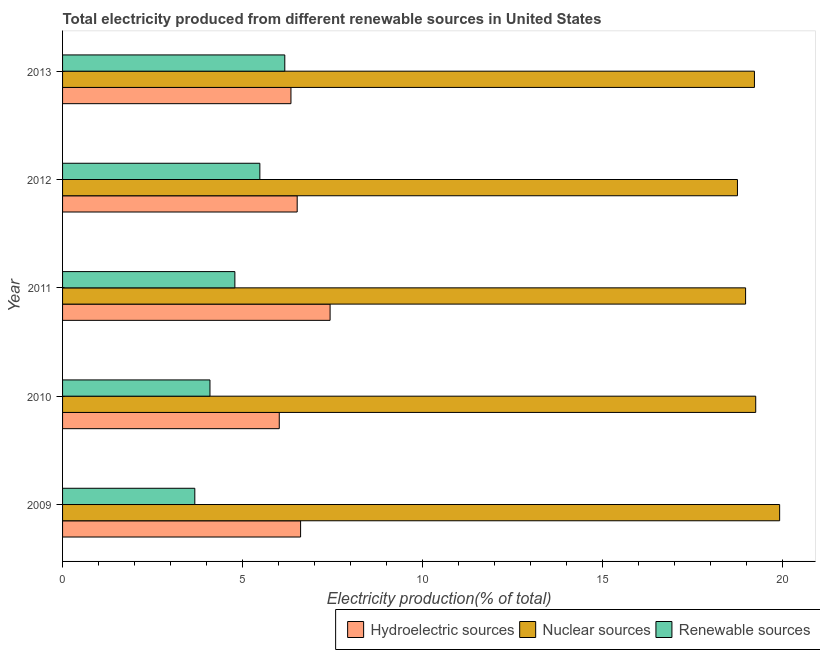How many different coloured bars are there?
Your answer should be compact. 3. Are the number of bars on each tick of the Y-axis equal?
Your response must be concise. Yes. How many bars are there on the 4th tick from the top?
Keep it short and to the point. 3. How many bars are there on the 2nd tick from the bottom?
Provide a short and direct response. 3. What is the label of the 1st group of bars from the top?
Provide a short and direct response. 2013. What is the percentage of electricity produced by renewable sources in 2011?
Ensure brevity in your answer.  4.79. Across all years, what is the maximum percentage of electricity produced by hydroelectric sources?
Your answer should be compact. 7.44. Across all years, what is the minimum percentage of electricity produced by renewable sources?
Make the answer very short. 3.68. In which year was the percentage of electricity produced by hydroelectric sources maximum?
Offer a very short reply. 2011. What is the total percentage of electricity produced by renewable sources in the graph?
Provide a succinct answer. 24.22. What is the difference between the percentage of electricity produced by renewable sources in 2009 and that in 2010?
Ensure brevity in your answer.  -0.42. What is the difference between the percentage of electricity produced by nuclear sources in 2009 and the percentage of electricity produced by hydroelectric sources in 2013?
Your response must be concise. 13.58. What is the average percentage of electricity produced by hydroelectric sources per year?
Make the answer very short. 6.59. In the year 2011, what is the difference between the percentage of electricity produced by nuclear sources and percentage of electricity produced by hydroelectric sources?
Make the answer very short. 11.55. In how many years, is the percentage of electricity produced by renewable sources greater than 7 %?
Give a very brief answer. 0. What is the ratio of the percentage of electricity produced by nuclear sources in 2009 to that in 2013?
Offer a terse response. 1.04. Is the percentage of electricity produced by hydroelectric sources in 2009 less than that in 2010?
Offer a very short reply. No. Is the difference between the percentage of electricity produced by hydroelectric sources in 2011 and 2012 greater than the difference between the percentage of electricity produced by nuclear sources in 2011 and 2012?
Offer a very short reply. Yes. What is the difference between the highest and the second highest percentage of electricity produced by hydroelectric sources?
Your answer should be very brief. 0.82. What is the difference between the highest and the lowest percentage of electricity produced by renewable sources?
Ensure brevity in your answer.  2.5. What does the 2nd bar from the top in 2013 represents?
Your response must be concise. Nuclear sources. What does the 1st bar from the bottom in 2009 represents?
Offer a very short reply. Hydroelectric sources. Is it the case that in every year, the sum of the percentage of electricity produced by hydroelectric sources and percentage of electricity produced by nuclear sources is greater than the percentage of electricity produced by renewable sources?
Ensure brevity in your answer.  Yes. How many years are there in the graph?
Your answer should be very brief. 5. What is the difference between two consecutive major ticks on the X-axis?
Your answer should be very brief. 5. Are the values on the major ticks of X-axis written in scientific E-notation?
Offer a very short reply. No. How are the legend labels stacked?
Provide a short and direct response. Horizontal. What is the title of the graph?
Offer a very short reply. Total electricity produced from different renewable sources in United States. What is the label or title of the X-axis?
Make the answer very short. Electricity production(% of total). What is the label or title of the Y-axis?
Give a very brief answer. Year. What is the Electricity production(% of total) of Hydroelectric sources in 2009?
Provide a succinct answer. 6.62. What is the Electricity production(% of total) in Nuclear sources in 2009?
Offer a very short reply. 19.93. What is the Electricity production(% of total) of Renewable sources in 2009?
Give a very brief answer. 3.68. What is the Electricity production(% of total) of Hydroelectric sources in 2010?
Keep it short and to the point. 6.02. What is the Electricity production(% of total) of Nuclear sources in 2010?
Provide a succinct answer. 19.27. What is the Electricity production(% of total) of Renewable sources in 2010?
Your answer should be very brief. 4.1. What is the Electricity production(% of total) of Hydroelectric sources in 2011?
Make the answer very short. 7.44. What is the Electricity production(% of total) in Nuclear sources in 2011?
Give a very brief answer. 18.98. What is the Electricity production(% of total) in Renewable sources in 2011?
Give a very brief answer. 4.79. What is the Electricity production(% of total) of Hydroelectric sources in 2012?
Provide a succinct answer. 6.52. What is the Electricity production(% of total) in Nuclear sources in 2012?
Your answer should be compact. 18.76. What is the Electricity production(% of total) of Renewable sources in 2012?
Offer a very short reply. 5.48. What is the Electricity production(% of total) of Hydroelectric sources in 2013?
Make the answer very short. 6.35. What is the Electricity production(% of total) in Nuclear sources in 2013?
Keep it short and to the point. 19.23. What is the Electricity production(% of total) in Renewable sources in 2013?
Make the answer very short. 6.18. Across all years, what is the maximum Electricity production(% of total) of Hydroelectric sources?
Ensure brevity in your answer.  7.44. Across all years, what is the maximum Electricity production(% of total) of Nuclear sources?
Provide a succinct answer. 19.93. Across all years, what is the maximum Electricity production(% of total) of Renewable sources?
Provide a succinct answer. 6.18. Across all years, what is the minimum Electricity production(% of total) in Hydroelectric sources?
Offer a very short reply. 6.02. Across all years, what is the minimum Electricity production(% of total) in Nuclear sources?
Keep it short and to the point. 18.76. Across all years, what is the minimum Electricity production(% of total) in Renewable sources?
Your response must be concise. 3.68. What is the total Electricity production(% of total) in Hydroelectric sources in the graph?
Offer a very short reply. 32.94. What is the total Electricity production(% of total) in Nuclear sources in the graph?
Give a very brief answer. 96.17. What is the total Electricity production(% of total) of Renewable sources in the graph?
Offer a terse response. 24.22. What is the difference between the Electricity production(% of total) in Hydroelectric sources in 2009 and that in 2010?
Keep it short and to the point. 0.59. What is the difference between the Electricity production(% of total) in Nuclear sources in 2009 and that in 2010?
Offer a very short reply. 0.66. What is the difference between the Electricity production(% of total) of Renewable sources in 2009 and that in 2010?
Keep it short and to the point. -0.42. What is the difference between the Electricity production(% of total) of Hydroelectric sources in 2009 and that in 2011?
Provide a succinct answer. -0.82. What is the difference between the Electricity production(% of total) in Nuclear sources in 2009 and that in 2011?
Ensure brevity in your answer.  0.95. What is the difference between the Electricity production(% of total) of Renewable sources in 2009 and that in 2011?
Your response must be concise. -1.11. What is the difference between the Electricity production(% of total) in Hydroelectric sources in 2009 and that in 2012?
Your response must be concise. 0.09. What is the difference between the Electricity production(% of total) in Nuclear sources in 2009 and that in 2012?
Your response must be concise. 1.17. What is the difference between the Electricity production(% of total) in Renewable sources in 2009 and that in 2012?
Your answer should be compact. -1.81. What is the difference between the Electricity production(% of total) of Hydroelectric sources in 2009 and that in 2013?
Your response must be concise. 0.27. What is the difference between the Electricity production(% of total) of Nuclear sources in 2009 and that in 2013?
Give a very brief answer. 0.7. What is the difference between the Electricity production(% of total) of Renewable sources in 2009 and that in 2013?
Offer a terse response. -2.5. What is the difference between the Electricity production(% of total) of Hydroelectric sources in 2010 and that in 2011?
Your answer should be compact. -1.41. What is the difference between the Electricity production(% of total) in Nuclear sources in 2010 and that in 2011?
Ensure brevity in your answer.  0.28. What is the difference between the Electricity production(% of total) of Renewable sources in 2010 and that in 2011?
Give a very brief answer. -0.69. What is the difference between the Electricity production(% of total) in Hydroelectric sources in 2010 and that in 2012?
Keep it short and to the point. -0.5. What is the difference between the Electricity production(% of total) of Nuclear sources in 2010 and that in 2012?
Give a very brief answer. 0.51. What is the difference between the Electricity production(% of total) of Renewable sources in 2010 and that in 2012?
Give a very brief answer. -1.39. What is the difference between the Electricity production(% of total) in Hydroelectric sources in 2010 and that in 2013?
Make the answer very short. -0.33. What is the difference between the Electricity production(% of total) of Nuclear sources in 2010 and that in 2013?
Ensure brevity in your answer.  0.04. What is the difference between the Electricity production(% of total) in Renewable sources in 2010 and that in 2013?
Provide a short and direct response. -2.08. What is the difference between the Electricity production(% of total) in Hydroelectric sources in 2011 and that in 2012?
Make the answer very short. 0.91. What is the difference between the Electricity production(% of total) of Nuclear sources in 2011 and that in 2012?
Offer a terse response. 0.23. What is the difference between the Electricity production(% of total) of Renewable sources in 2011 and that in 2012?
Give a very brief answer. -0.69. What is the difference between the Electricity production(% of total) of Hydroelectric sources in 2011 and that in 2013?
Your response must be concise. 1.09. What is the difference between the Electricity production(% of total) of Nuclear sources in 2011 and that in 2013?
Your answer should be very brief. -0.25. What is the difference between the Electricity production(% of total) in Renewable sources in 2011 and that in 2013?
Your answer should be compact. -1.39. What is the difference between the Electricity production(% of total) in Hydroelectric sources in 2012 and that in 2013?
Your answer should be very brief. 0.17. What is the difference between the Electricity production(% of total) in Nuclear sources in 2012 and that in 2013?
Ensure brevity in your answer.  -0.47. What is the difference between the Electricity production(% of total) of Renewable sources in 2012 and that in 2013?
Offer a very short reply. -0.69. What is the difference between the Electricity production(% of total) of Hydroelectric sources in 2009 and the Electricity production(% of total) of Nuclear sources in 2010?
Your response must be concise. -12.65. What is the difference between the Electricity production(% of total) of Hydroelectric sources in 2009 and the Electricity production(% of total) of Renewable sources in 2010?
Offer a terse response. 2.52. What is the difference between the Electricity production(% of total) of Nuclear sources in 2009 and the Electricity production(% of total) of Renewable sources in 2010?
Keep it short and to the point. 15.83. What is the difference between the Electricity production(% of total) of Hydroelectric sources in 2009 and the Electricity production(% of total) of Nuclear sources in 2011?
Your response must be concise. -12.37. What is the difference between the Electricity production(% of total) in Hydroelectric sources in 2009 and the Electricity production(% of total) in Renewable sources in 2011?
Ensure brevity in your answer.  1.83. What is the difference between the Electricity production(% of total) in Nuclear sources in 2009 and the Electricity production(% of total) in Renewable sources in 2011?
Offer a terse response. 15.14. What is the difference between the Electricity production(% of total) in Hydroelectric sources in 2009 and the Electricity production(% of total) in Nuclear sources in 2012?
Your answer should be compact. -12.14. What is the difference between the Electricity production(% of total) of Hydroelectric sources in 2009 and the Electricity production(% of total) of Renewable sources in 2012?
Offer a very short reply. 1.13. What is the difference between the Electricity production(% of total) in Nuclear sources in 2009 and the Electricity production(% of total) in Renewable sources in 2012?
Provide a succinct answer. 14.45. What is the difference between the Electricity production(% of total) in Hydroelectric sources in 2009 and the Electricity production(% of total) in Nuclear sources in 2013?
Keep it short and to the point. -12.61. What is the difference between the Electricity production(% of total) of Hydroelectric sources in 2009 and the Electricity production(% of total) of Renewable sources in 2013?
Your answer should be compact. 0.44. What is the difference between the Electricity production(% of total) in Nuclear sources in 2009 and the Electricity production(% of total) in Renewable sources in 2013?
Provide a short and direct response. 13.75. What is the difference between the Electricity production(% of total) of Hydroelectric sources in 2010 and the Electricity production(% of total) of Nuclear sources in 2011?
Your response must be concise. -12.96. What is the difference between the Electricity production(% of total) in Hydroelectric sources in 2010 and the Electricity production(% of total) in Renewable sources in 2011?
Your answer should be very brief. 1.23. What is the difference between the Electricity production(% of total) in Nuclear sources in 2010 and the Electricity production(% of total) in Renewable sources in 2011?
Provide a succinct answer. 14.48. What is the difference between the Electricity production(% of total) in Hydroelectric sources in 2010 and the Electricity production(% of total) in Nuclear sources in 2012?
Your response must be concise. -12.74. What is the difference between the Electricity production(% of total) in Hydroelectric sources in 2010 and the Electricity production(% of total) in Renewable sources in 2012?
Your answer should be compact. 0.54. What is the difference between the Electricity production(% of total) of Nuclear sources in 2010 and the Electricity production(% of total) of Renewable sources in 2012?
Your answer should be compact. 13.78. What is the difference between the Electricity production(% of total) of Hydroelectric sources in 2010 and the Electricity production(% of total) of Nuclear sources in 2013?
Your answer should be compact. -13.21. What is the difference between the Electricity production(% of total) of Hydroelectric sources in 2010 and the Electricity production(% of total) of Renewable sources in 2013?
Give a very brief answer. -0.15. What is the difference between the Electricity production(% of total) in Nuclear sources in 2010 and the Electricity production(% of total) in Renewable sources in 2013?
Your answer should be compact. 13.09. What is the difference between the Electricity production(% of total) in Hydroelectric sources in 2011 and the Electricity production(% of total) in Nuclear sources in 2012?
Your response must be concise. -11.32. What is the difference between the Electricity production(% of total) in Hydroelectric sources in 2011 and the Electricity production(% of total) in Renewable sources in 2012?
Make the answer very short. 1.95. What is the difference between the Electricity production(% of total) of Nuclear sources in 2011 and the Electricity production(% of total) of Renewable sources in 2012?
Offer a terse response. 13.5. What is the difference between the Electricity production(% of total) of Hydroelectric sources in 2011 and the Electricity production(% of total) of Nuclear sources in 2013?
Offer a terse response. -11.79. What is the difference between the Electricity production(% of total) of Hydroelectric sources in 2011 and the Electricity production(% of total) of Renewable sources in 2013?
Offer a very short reply. 1.26. What is the difference between the Electricity production(% of total) in Nuclear sources in 2011 and the Electricity production(% of total) in Renewable sources in 2013?
Provide a succinct answer. 12.81. What is the difference between the Electricity production(% of total) of Hydroelectric sources in 2012 and the Electricity production(% of total) of Nuclear sources in 2013?
Your answer should be compact. -12.71. What is the difference between the Electricity production(% of total) in Hydroelectric sources in 2012 and the Electricity production(% of total) in Renewable sources in 2013?
Ensure brevity in your answer.  0.34. What is the difference between the Electricity production(% of total) of Nuclear sources in 2012 and the Electricity production(% of total) of Renewable sources in 2013?
Offer a terse response. 12.58. What is the average Electricity production(% of total) of Hydroelectric sources per year?
Provide a short and direct response. 6.59. What is the average Electricity production(% of total) of Nuclear sources per year?
Provide a short and direct response. 19.23. What is the average Electricity production(% of total) of Renewable sources per year?
Offer a terse response. 4.84. In the year 2009, what is the difference between the Electricity production(% of total) of Hydroelectric sources and Electricity production(% of total) of Nuclear sources?
Ensure brevity in your answer.  -13.31. In the year 2009, what is the difference between the Electricity production(% of total) of Hydroelectric sources and Electricity production(% of total) of Renewable sources?
Ensure brevity in your answer.  2.94. In the year 2009, what is the difference between the Electricity production(% of total) in Nuclear sources and Electricity production(% of total) in Renewable sources?
Your answer should be very brief. 16.26. In the year 2010, what is the difference between the Electricity production(% of total) of Hydroelectric sources and Electricity production(% of total) of Nuclear sources?
Make the answer very short. -13.24. In the year 2010, what is the difference between the Electricity production(% of total) in Hydroelectric sources and Electricity production(% of total) in Renewable sources?
Offer a terse response. 1.93. In the year 2010, what is the difference between the Electricity production(% of total) in Nuclear sources and Electricity production(% of total) in Renewable sources?
Offer a terse response. 15.17. In the year 2011, what is the difference between the Electricity production(% of total) in Hydroelectric sources and Electricity production(% of total) in Nuclear sources?
Offer a terse response. -11.55. In the year 2011, what is the difference between the Electricity production(% of total) in Hydroelectric sources and Electricity production(% of total) in Renewable sources?
Your answer should be very brief. 2.65. In the year 2011, what is the difference between the Electricity production(% of total) in Nuclear sources and Electricity production(% of total) in Renewable sources?
Provide a succinct answer. 14.2. In the year 2012, what is the difference between the Electricity production(% of total) in Hydroelectric sources and Electricity production(% of total) in Nuclear sources?
Your answer should be compact. -12.24. In the year 2012, what is the difference between the Electricity production(% of total) in Hydroelectric sources and Electricity production(% of total) in Renewable sources?
Offer a terse response. 1.04. In the year 2012, what is the difference between the Electricity production(% of total) in Nuclear sources and Electricity production(% of total) in Renewable sources?
Offer a terse response. 13.27. In the year 2013, what is the difference between the Electricity production(% of total) of Hydroelectric sources and Electricity production(% of total) of Nuclear sources?
Make the answer very short. -12.88. In the year 2013, what is the difference between the Electricity production(% of total) in Hydroelectric sources and Electricity production(% of total) in Renewable sources?
Ensure brevity in your answer.  0.17. In the year 2013, what is the difference between the Electricity production(% of total) in Nuclear sources and Electricity production(% of total) in Renewable sources?
Offer a very short reply. 13.05. What is the ratio of the Electricity production(% of total) of Hydroelectric sources in 2009 to that in 2010?
Ensure brevity in your answer.  1.1. What is the ratio of the Electricity production(% of total) of Nuclear sources in 2009 to that in 2010?
Provide a short and direct response. 1.03. What is the ratio of the Electricity production(% of total) of Renewable sources in 2009 to that in 2010?
Your response must be concise. 0.9. What is the ratio of the Electricity production(% of total) of Hydroelectric sources in 2009 to that in 2011?
Offer a terse response. 0.89. What is the ratio of the Electricity production(% of total) of Nuclear sources in 2009 to that in 2011?
Make the answer very short. 1.05. What is the ratio of the Electricity production(% of total) in Renewable sources in 2009 to that in 2011?
Your answer should be compact. 0.77. What is the ratio of the Electricity production(% of total) of Hydroelectric sources in 2009 to that in 2012?
Keep it short and to the point. 1.01. What is the ratio of the Electricity production(% of total) of Renewable sources in 2009 to that in 2012?
Keep it short and to the point. 0.67. What is the ratio of the Electricity production(% of total) in Hydroelectric sources in 2009 to that in 2013?
Make the answer very short. 1.04. What is the ratio of the Electricity production(% of total) of Nuclear sources in 2009 to that in 2013?
Offer a terse response. 1.04. What is the ratio of the Electricity production(% of total) of Renewable sources in 2009 to that in 2013?
Your answer should be compact. 0.59. What is the ratio of the Electricity production(% of total) of Hydroelectric sources in 2010 to that in 2011?
Provide a short and direct response. 0.81. What is the ratio of the Electricity production(% of total) in Nuclear sources in 2010 to that in 2011?
Give a very brief answer. 1.01. What is the ratio of the Electricity production(% of total) in Renewable sources in 2010 to that in 2011?
Make the answer very short. 0.86. What is the ratio of the Electricity production(% of total) of Hydroelectric sources in 2010 to that in 2012?
Give a very brief answer. 0.92. What is the ratio of the Electricity production(% of total) in Nuclear sources in 2010 to that in 2012?
Offer a very short reply. 1.03. What is the ratio of the Electricity production(% of total) in Renewable sources in 2010 to that in 2012?
Make the answer very short. 0.75. What is the ratio of the Electricity production(% of total) of Hydroelectric sources in 2010 to that in 2013?
Your answer should be compact. 0.95. What is the ratio of the Electricity production(% of total) in Renewable sources in 2010 to that in 2013?
Provide a succinct answer. 0.66. What is the ratio of the Electricity production(% of total) of Hydroelectric sources in 2011 to that in 2012?
Your response must be concise. 1.14. What is the ratio of the Electricity production(% of total) of Nuclear sources in 2011 to that in 2012?
Provide a succinct answer. 1.01. What is the ratio of the Electricity production(% of total) of Renewable sources in 2011 to that in 2012?
Provide a succinct answer. 0.87. What is the ratio of the Electricity production(% of total) of Hydroelectric sources in 2011 to that in 2013?
Provide a succinct answer. 1.17. What is the ratio of the Electricity production(% of total) in Nuclear sources in 2011 to that in 2013?
Keep it short and to the point. 0.99. What is the ratio of the Electricity production(% of total) in Renewable sources in 2011 to that in 2013?
Give a very brief answer. 0.78. What is the ratio of the Electricity production(% of total) in Hydroelectric sources in 2012 to that in 2013?
Provide a short and direct response. 1.03. What is the ratio of the Electricity production(% of total) in Nuclear sources in 2012 to that in 2013?
Your answer should be very brief. 0.98. What is the ratio of the Electricity production(% of total) in Renewable sources in 2012 to that in 2013?
Your answer should be compact. 0.89. What is the difference between the highest and the second highest Electricity production(% of total) of Hydroelectric sources?
Your answer should be compact. 0.82. What is the difference between the highest and the second highest Electricity production(% of total) of Nuclear sources?
Give a very brief answer. 0.66. What is the difference between the highest and the second highest Electricity production(% of total) of Renewable sources?
Make the answer very short. 0.69. What is the difference between the highest and the lowest Electricity production(% of total) in Hydroelectric sources?
Provide a short and direct response. 1.41. What is the difference between the highest and the lowest Electricity production(% of total) in Nuclear sources?
Provide a succinct answer. 1.17. What is the difference between the highest and the lowest Electricity production(% of total) of Renewable sources?
Provide a succinct answer. 2.5. 